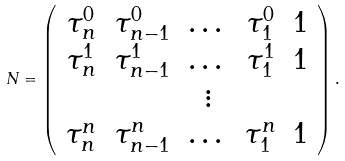Convert formula to latex. <formula><loc_0><loc_0><loc_500><loc_500>N = \left ( \begin{array} { c c c c c } \tau _ { n } ^ { 0 } & \tau _ { n - 1 } ^ { 0 } & \dots & \tau _ { 1 } ^ { 0 } & 1 \\ \tau _ { n } ^ { 1 } & \tau _ { n - 1 } ^ { 1 } & \dots & \tau _ { 1 } ^ { 1 } & 1 \\ & & \vdots \\ \tau _ { n } ^ { n } & \tau _ { n - 1 } ^ { n } & \dots & \tau _ { 1 } ^ { n } & 1 \\ \end{array} \right ) .</formula> 